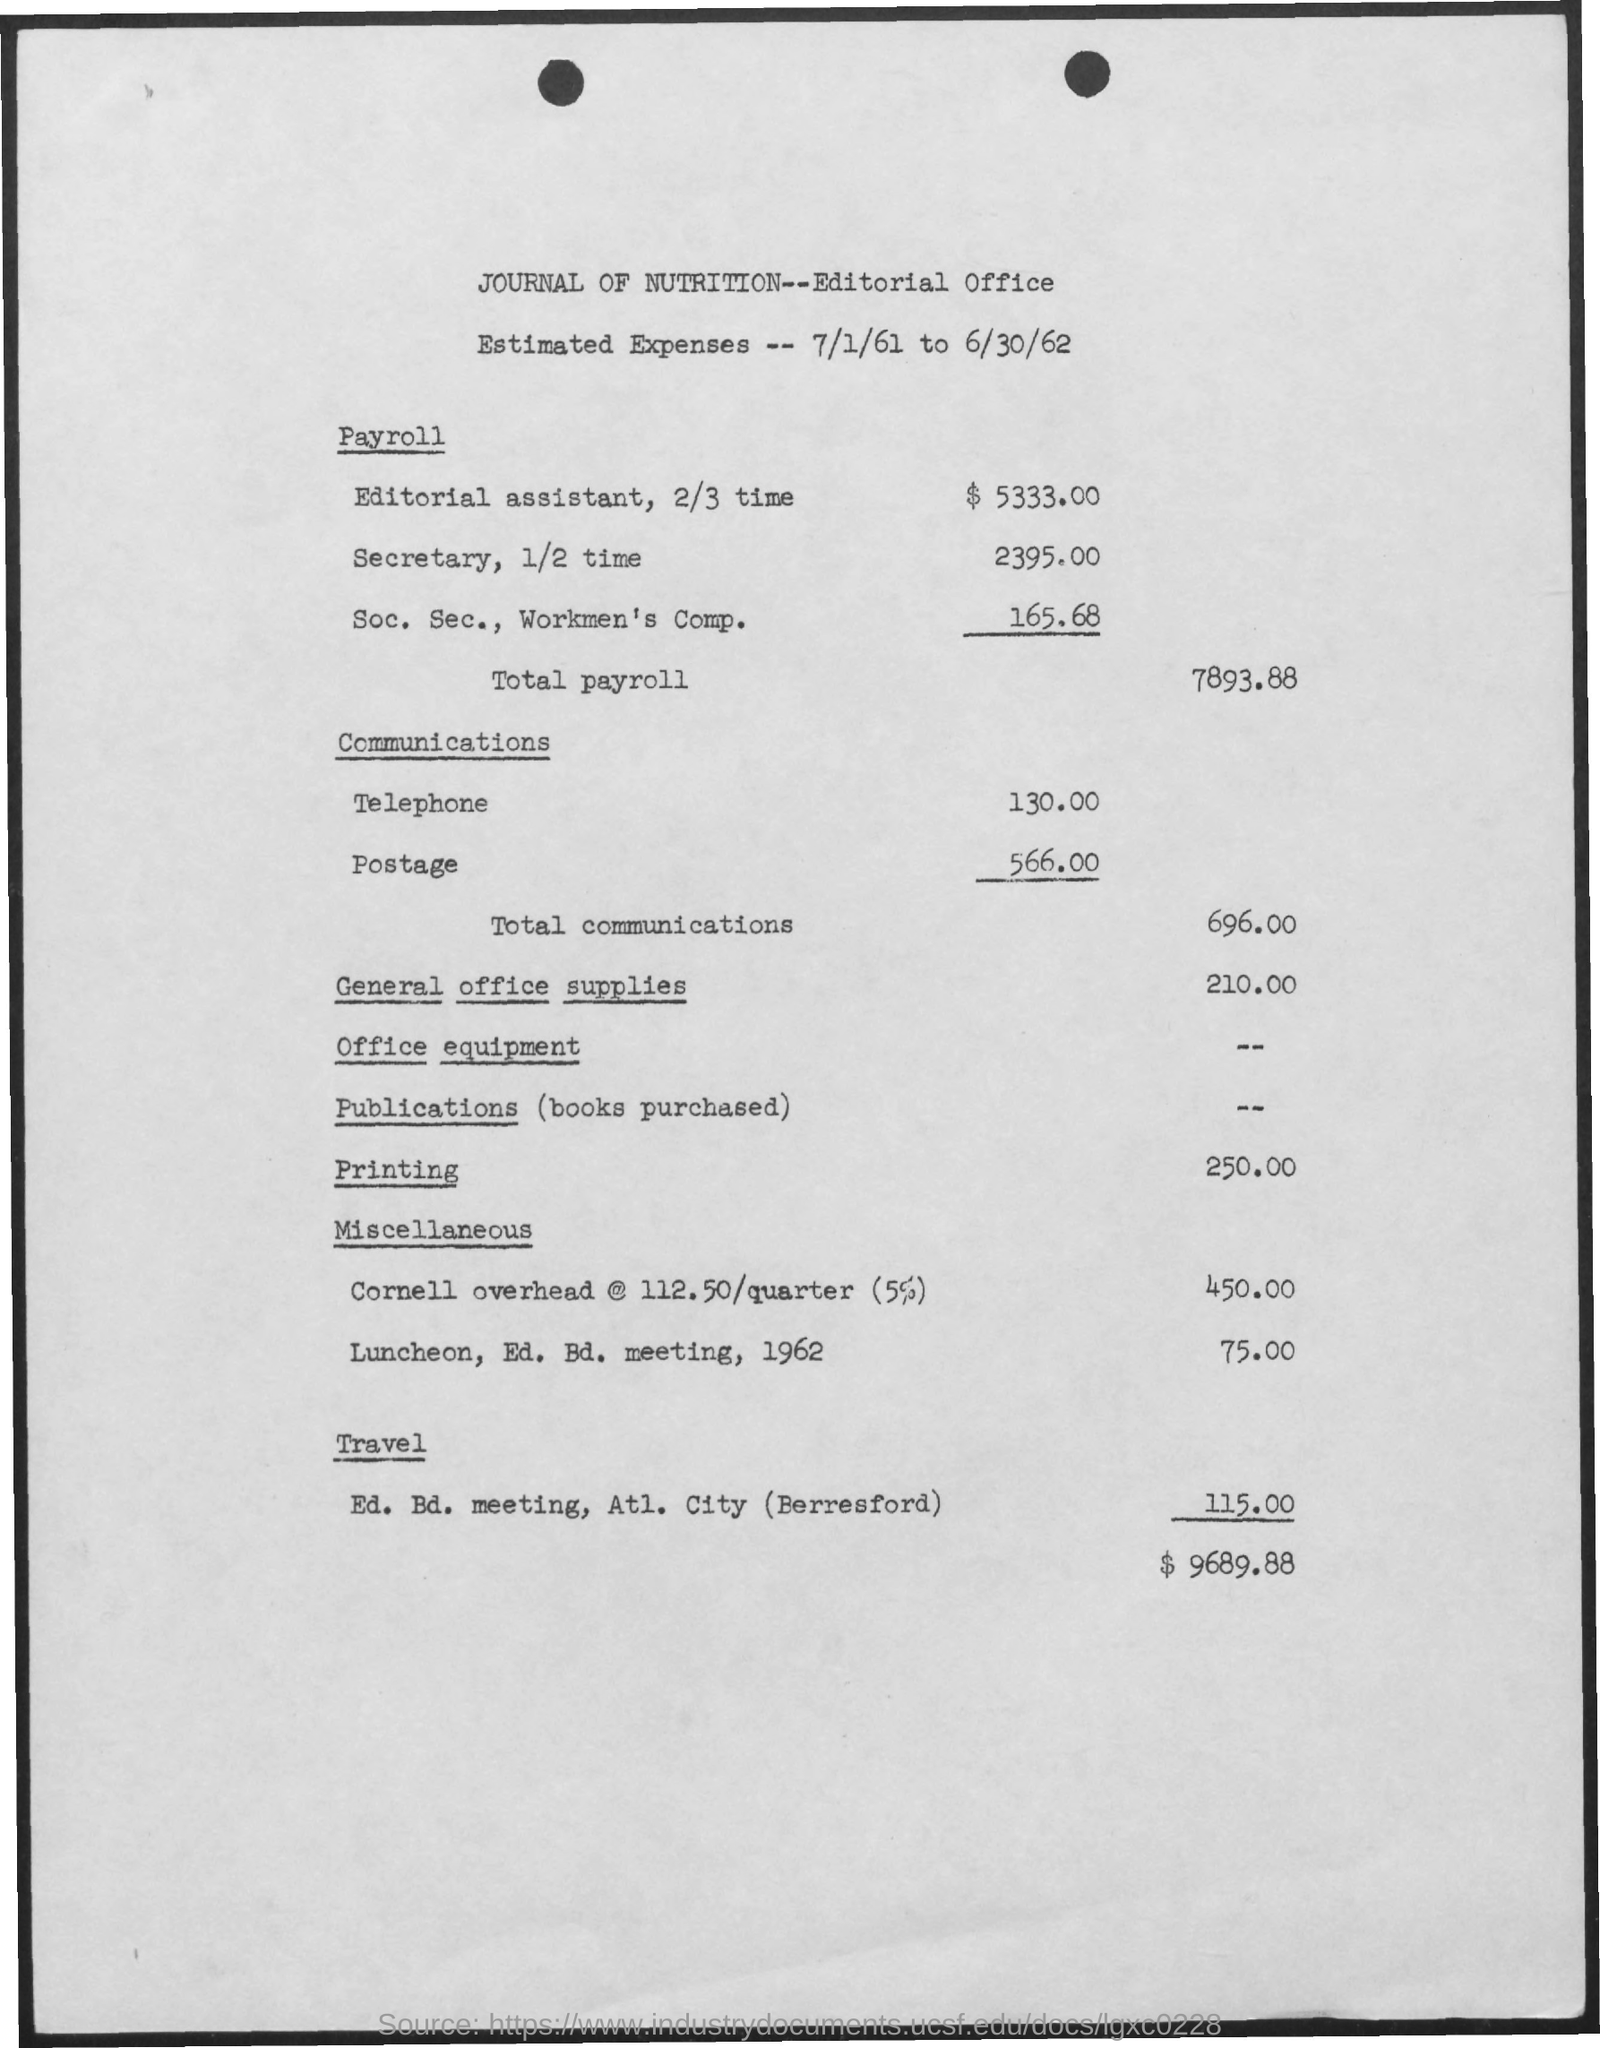Identify some key points in this picture. The amount for printing is 250.00. There is a telephone bill for 130.00. The amount for total communications is 696.00. The payroll for an editorial assistant working 2/3 time is $5,333.00. The payroll for Social Security and Workers' Compensation is 165.68. 